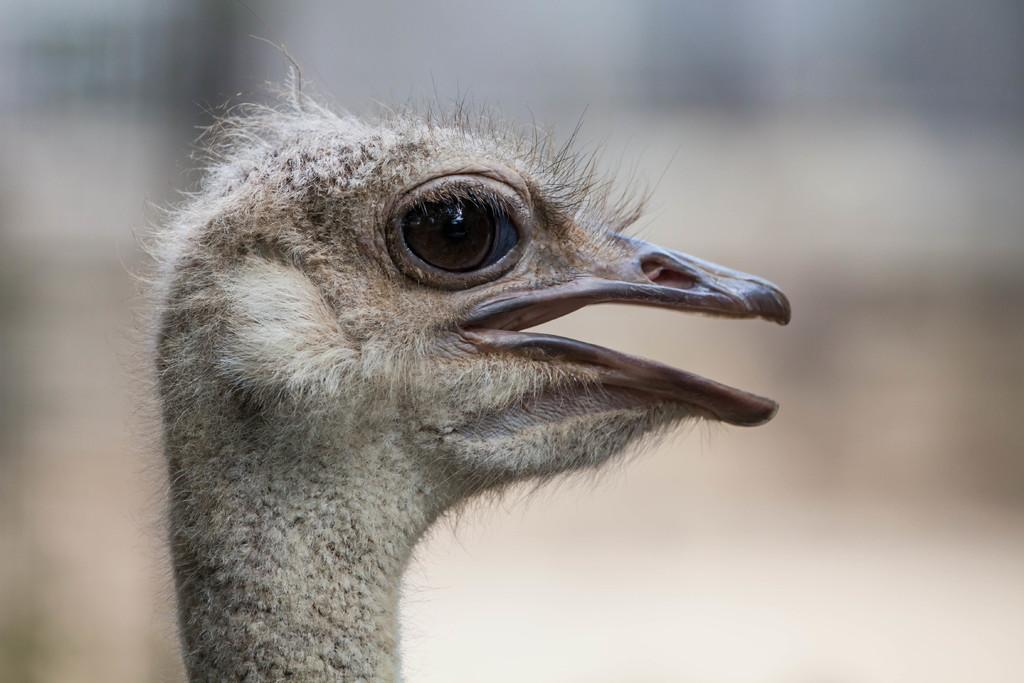What type of bird is on the left side of the image? There is a gray color bird on the left side of the image. What is the bird doing in the image? The bird has its mouth opened. Can you describe the background of the image? The background of the image is blurred. What statement does the bird make in the image? There is no indication in the image that the bird is making a statement, as birds do not have the ability to communicate through language. 